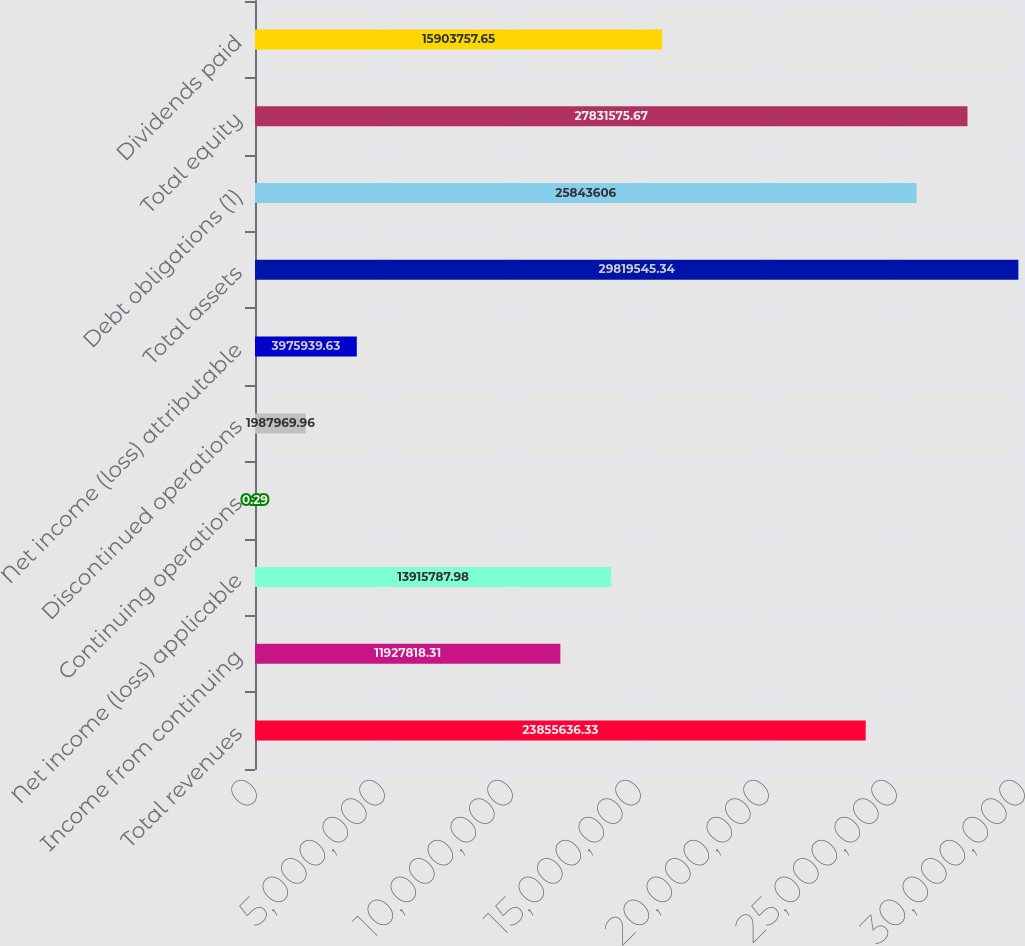Convert chart. <chart><loc_0><loc_0><loc_500><loc_500><bar_chart><fcel>Total revenues<fcel>Income from continuing<fcel>Net income (loss) applicable<fcel>Continuing operations<fcel>Discontinued operations<fcel>Net income (loss) attributable<fcel>Total assets<fcel>Debt obligations (1)<fcel>Total equity<fcel>Dividends paid<nl><fcel>2.38556e+07<fcel>1.19278e+07<fcel>1.39158e+07<fcel>0.29<fcel>1.98797e+06<fcel>3.97594e+06<fcel>2.98195e+07<fcel>2.58436e+07<fcel>2.78316e+07<fcel>1.59038e+07<nl></chart> 